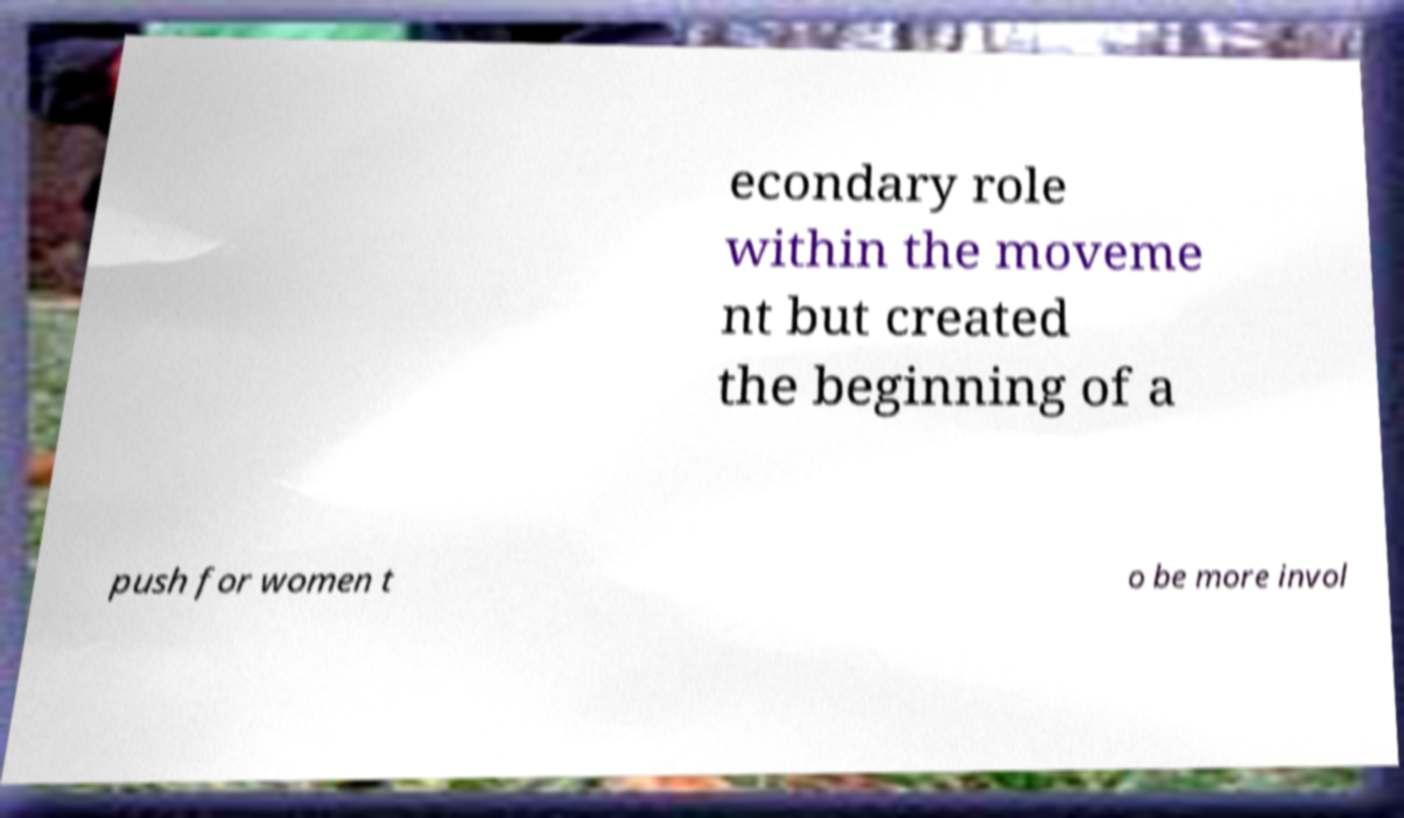Could you extract and type out the text from this image? econdary role within the moveme nt but created the beginning of a push for women t o be more invol 